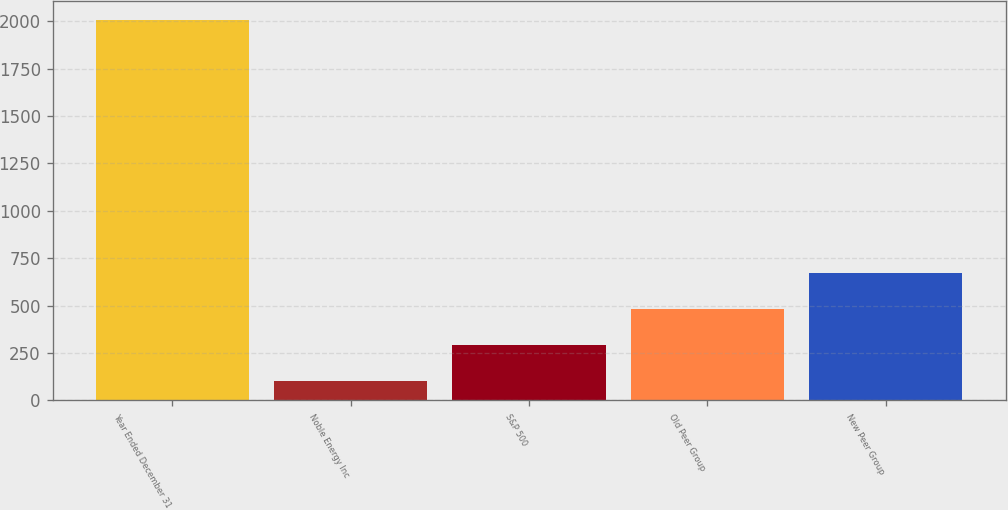Convert chart. <chart><loc_0><loc_0><loc_500><loc_500><bar_chart><fcel>Year Ended December 31<fcel>Noble Energy Inc<fcel>S&P 500<fcel>Old Peer Group<fcel>New Peer Group<nl><fcel>2005<fcel>100<fcel>290.5<fcel>481<fcel>671.5<nl></chart> 